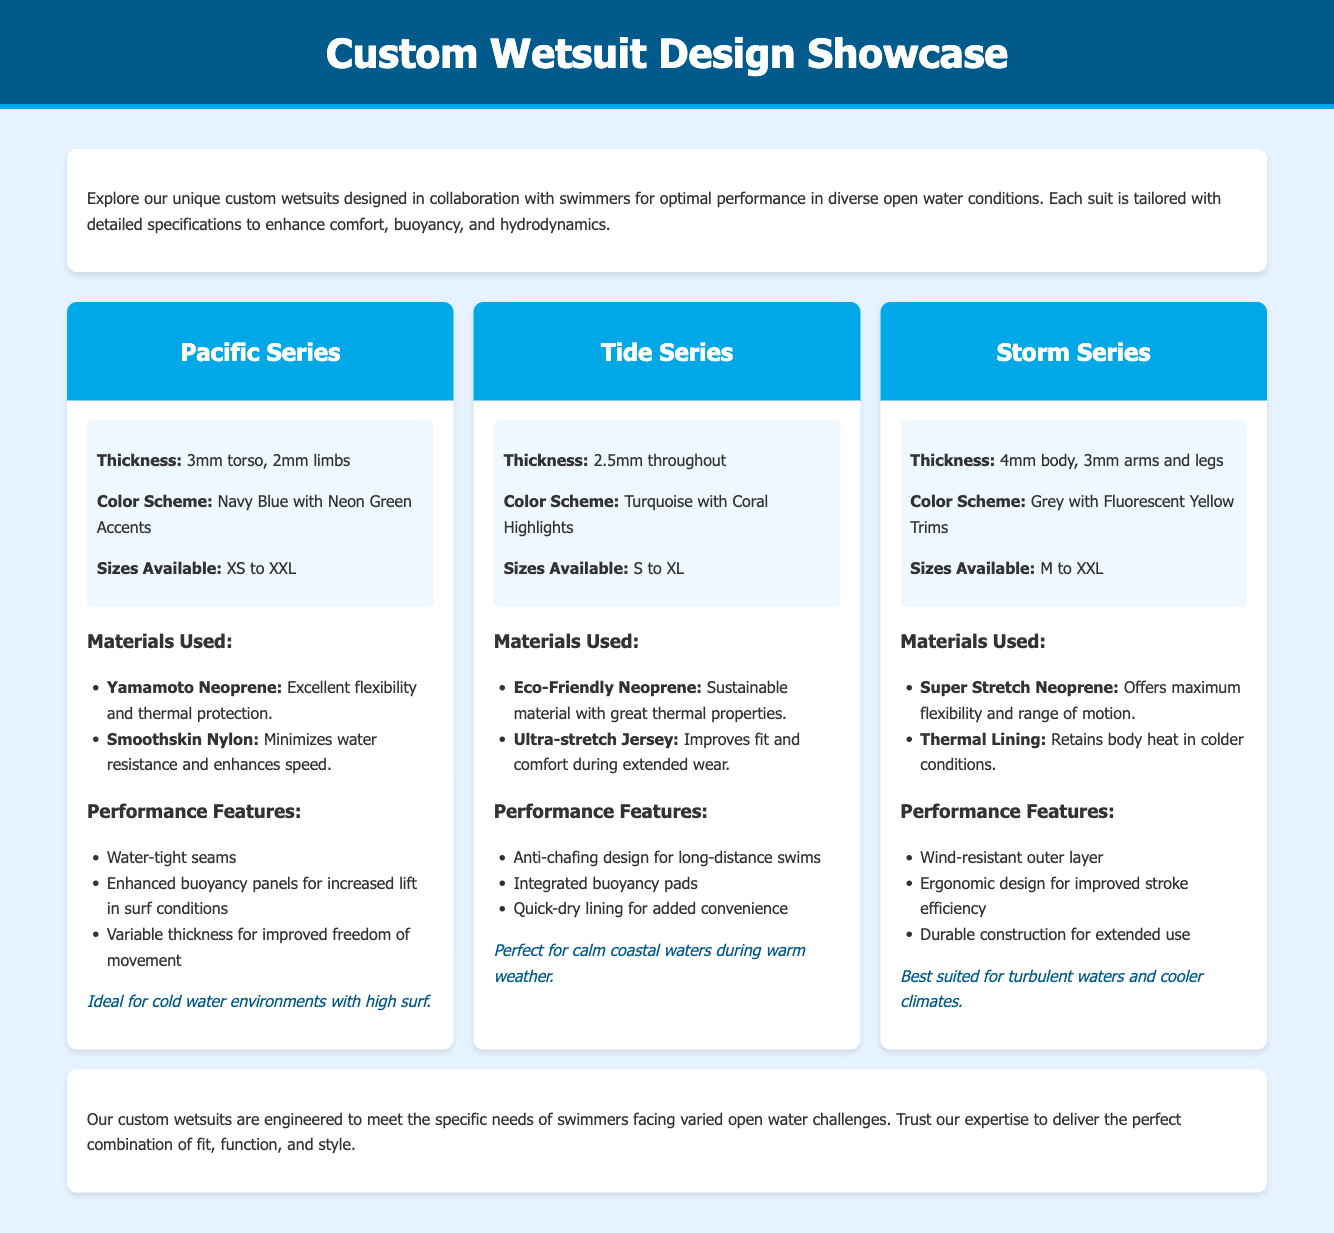What is the thickness of the Pacific Series? The document specifies that the Pacific Series has a thickness of 3mm torso and 2mm limbs.
Answer: 3mm torso, 2mm limbs What is the color scheme of the Tide Series? The color scheme of the Tide Series is mentioned as Turquoise with Coral Highlights.
Answer: Turquoise with Coral Highlights Which materials are used in the Storm Series? The document lists materials used in the Storm Series as Super Stretch Neoprene and Thermal Lining.
Answer: Super Stretch Neoprene, Thermal Lining What are the sizes available for the Pacific Series? The sizes available for the Pacific Series range from XS to XXL, as indicated in the document.
Answer: XS to XXL What is the optimized condition for the Tide Series? The document states that the Tide Series is perfect for calm coastal waters during warm weather.
Answer: Calm coastal waters during warm weather Which performance feature is highlighted for the Storm Series? The Storm Series features a wind-resistant outer layer, noted in the performance features section.
Answer: Wind-resistant outer layer What is the thickness of the body in the Storm Series? The thickness of the body in the Storm Series is specifically stated as 4mm.
Answer: 4mm What specific function does the Enhanced buoyancy panels serve in the Pacific Series? The Enhanced buoyancy panels are designed for increased lift in surf conditions, according to the document.
Answer: Increased lift in surf conditions What is the main benefit of the Eco-Friendly Neoprene used in the Tide Series? The Eco-Friendly Neoprene is noted for being a sustainable material with great thermal properties.
Answer: Sustainable material with great thermal properties 